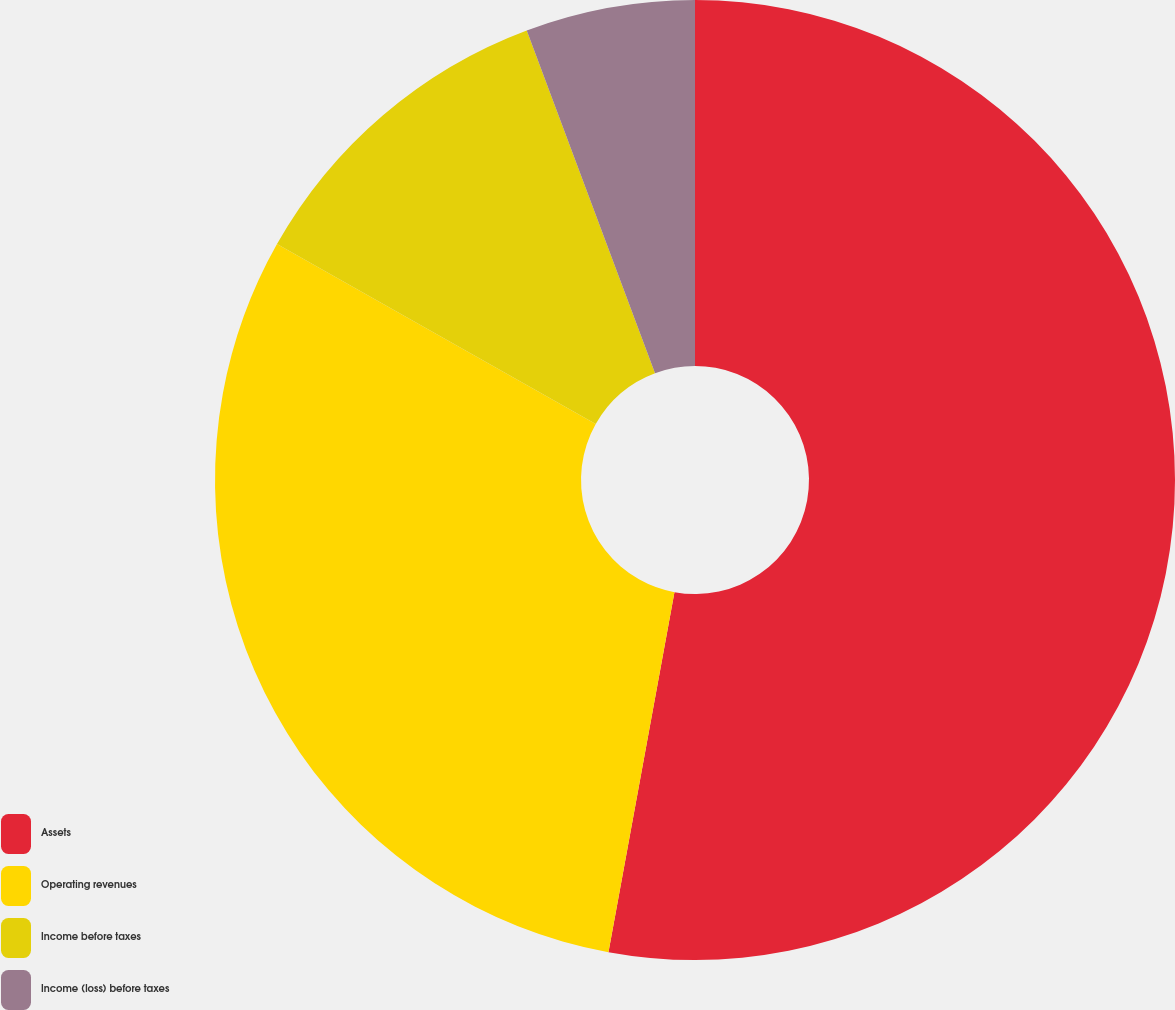Convert chart. <chart><loc_0><loc_0><loc_500><loc_500><pie_chart><fcel>Assets<fcel>Operating revenues<fcel>Income before taxes<fcel>Income (loss) before taxes<nl><fcel>52.88%<fcel>30.29%<fcel>11.12%<fcel>5.7%<nl></chart> 